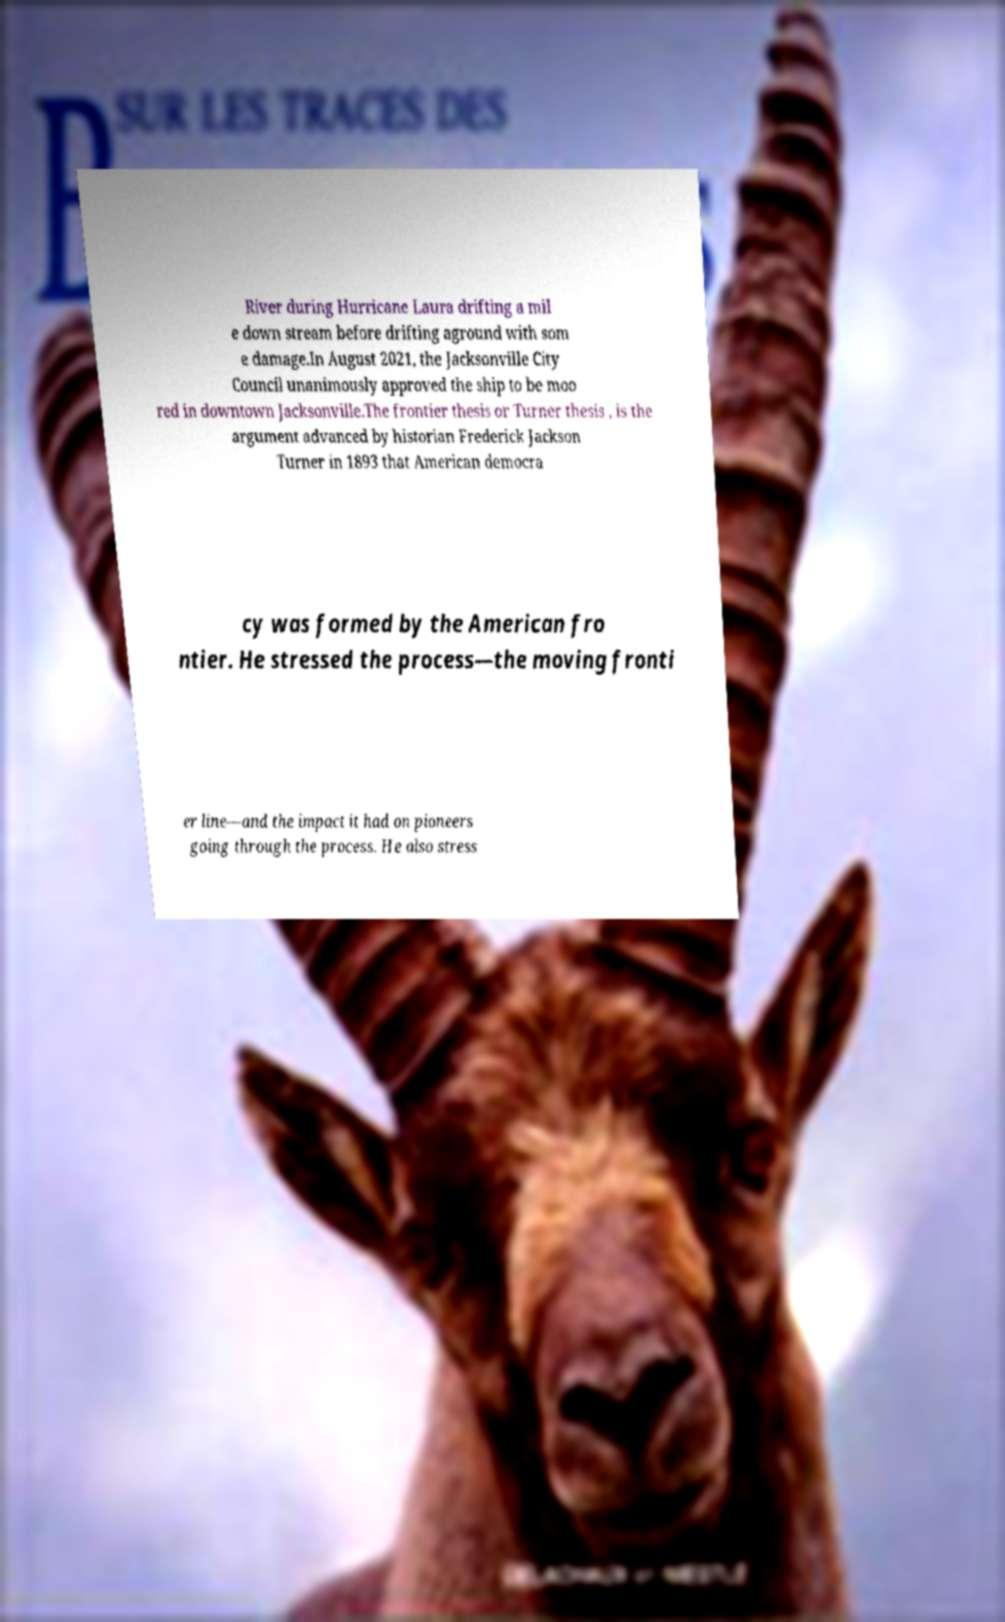There's text embedded in this image that I need extracted. Can you transcribe it verbatim? River during Hurricane Laura drifting a mil e down stream before drifting aground with som e damage.In August 2021, the Jacksonville City Council unanimously approved the ship to be moo red in downtown Jacksonville.The frontier thesis or Turner thesis , is the argument advanced by historian Frederick Jackson Turner in 1893 that American democra cy was formed by the American fro ntier. He stressed the process—the moving fronti er line—and the impact it had on pioneers going through the process. He also stress 